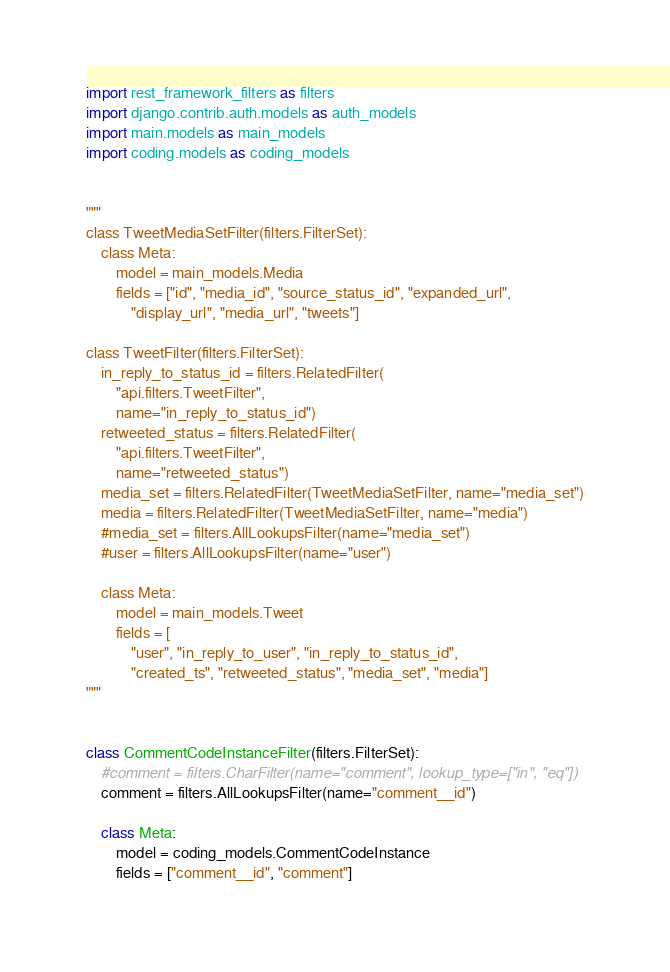Convert code to text. <code><loc_0><loc_0><loc_500><loc_500><_Python_>import rest_framework_filters as filters
import django.contrib.auth.models as auth_models
import main.models as main_models
import coding.models as coding_models


"""
class TweetMediaSetFilter(filters.FilterSet):
    class Meta:
        model = main_models.Media
        fields = ["id", "media_id", "source_status_id", "expanded_url", 
            "display_url", "media_url", "tweets"]

class TweetFilter(filters.FilterSet):
    in_reply_to_status_id = filters.RelatedFilter(
        "api.filters.TweetFilter",
        name="in_reply_to_status_id")
    retweeted_status = filters.RelatedFilter(
        "api.filters.TweetFilter",
        name="retweeted_status")
    media_set = filters.RelatedFilter(TweetMediaSetFilter, name="media_set")
    media = filters.RelatedFilter(TweetMediaSetFilter, name="media")
    #media_set = filters.AllLookupsFilter(name="media_set")
    #user = filters.AllLookupsFilter(name="user")

    class Meta:
        model = main_models.Tweet
        fields = [
            "user", "in_reply_to_user", "in_reply_to_status_id",
            "created_ts", "retweeted_status", "media_set", "media"]
"""


class CommentCodeInstanceFilter(filters.FilterSet):
    #comment = filters.CharFilter(name="comment", lookup_type=["in", "eq"])
    comment = filters.AllLookupsFilter(name="comment__id")

    class Meta:
        model = coding_models.CommentCodeInstance
        fields = ["comment__id", "comment"]</code> 